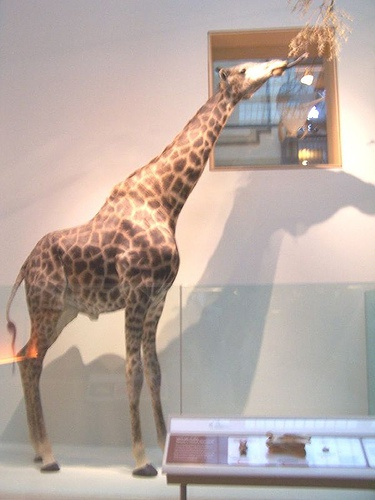Describe the objects in this image and their specific colors. I can see a giraffe in darkgray, gray, and tan tones in this image. 